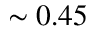<formula> <loc_0><loc_0><loc_500><loc_500>\sim 0 . 4 5</formula> 